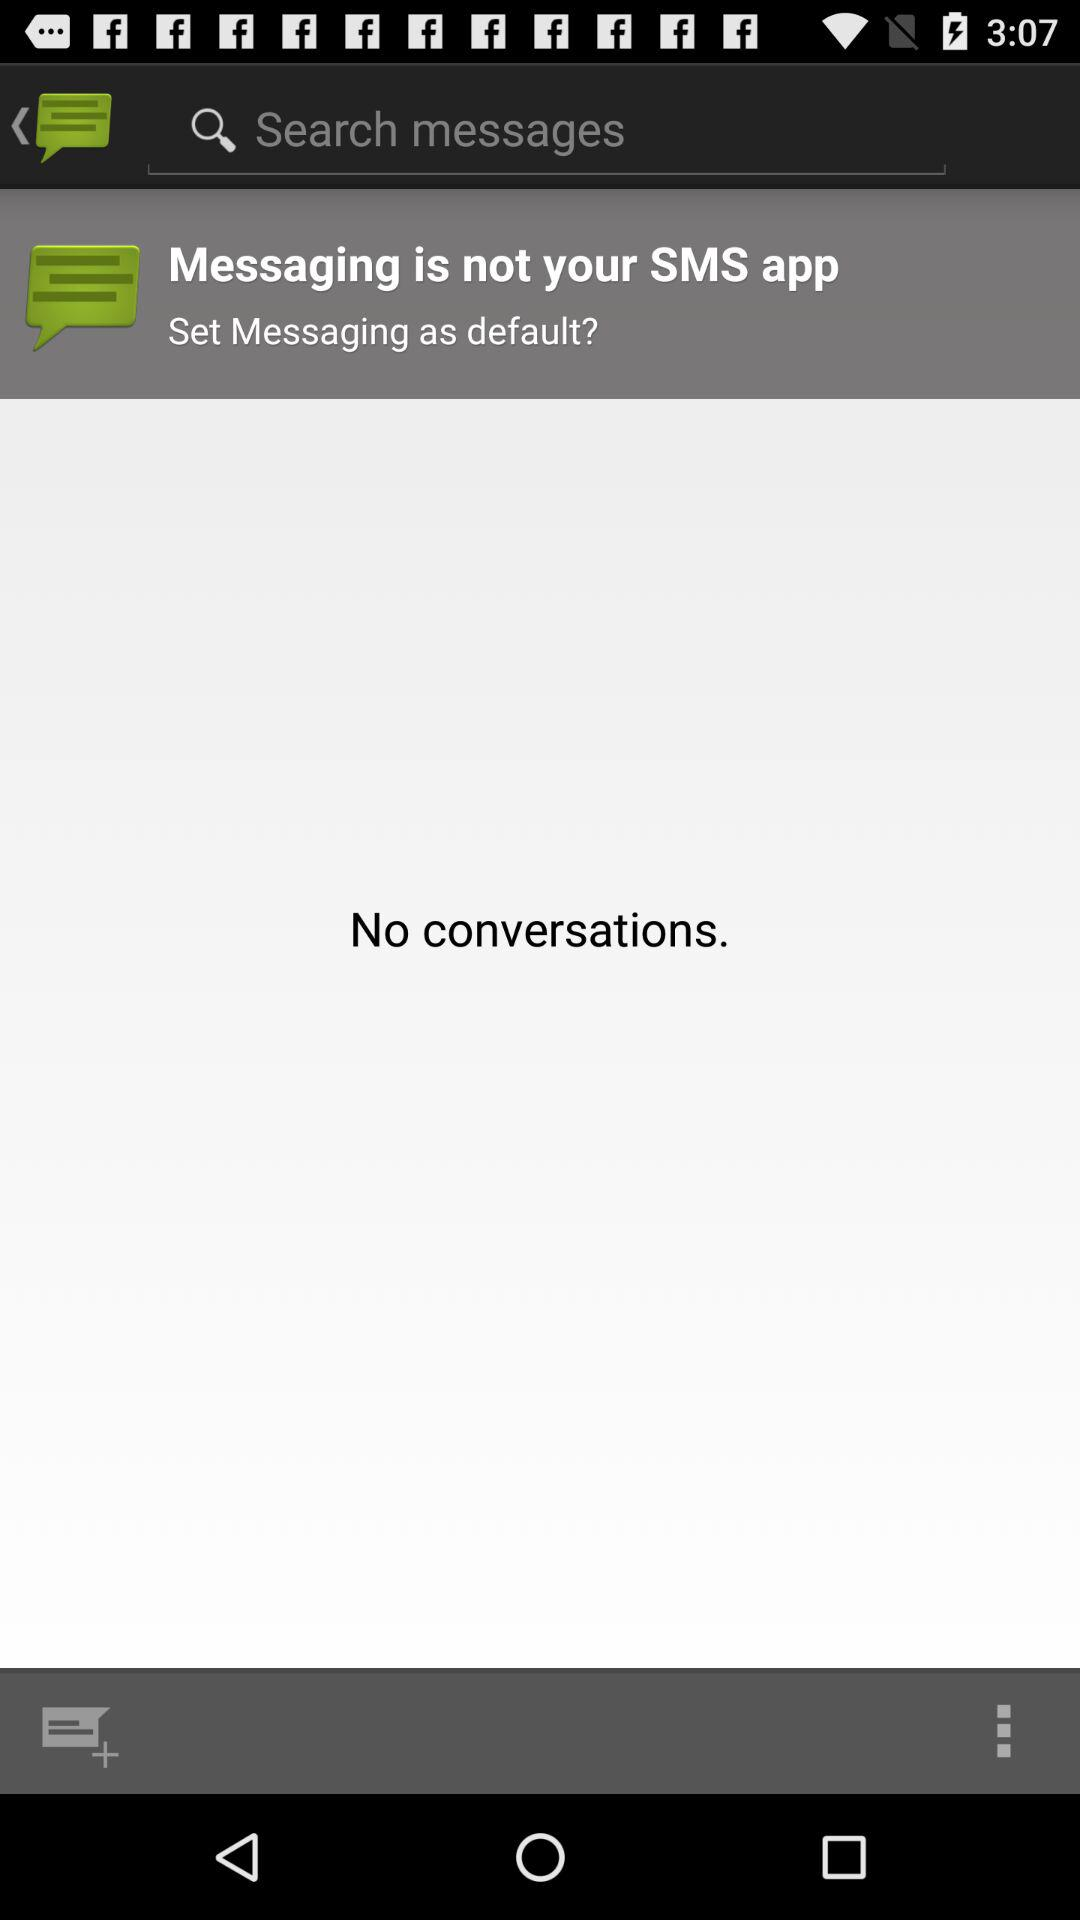What is the message displayed on the application screen?
Answer the question using a single word or phrase. The message displayed on the application screen is "No conversations." 